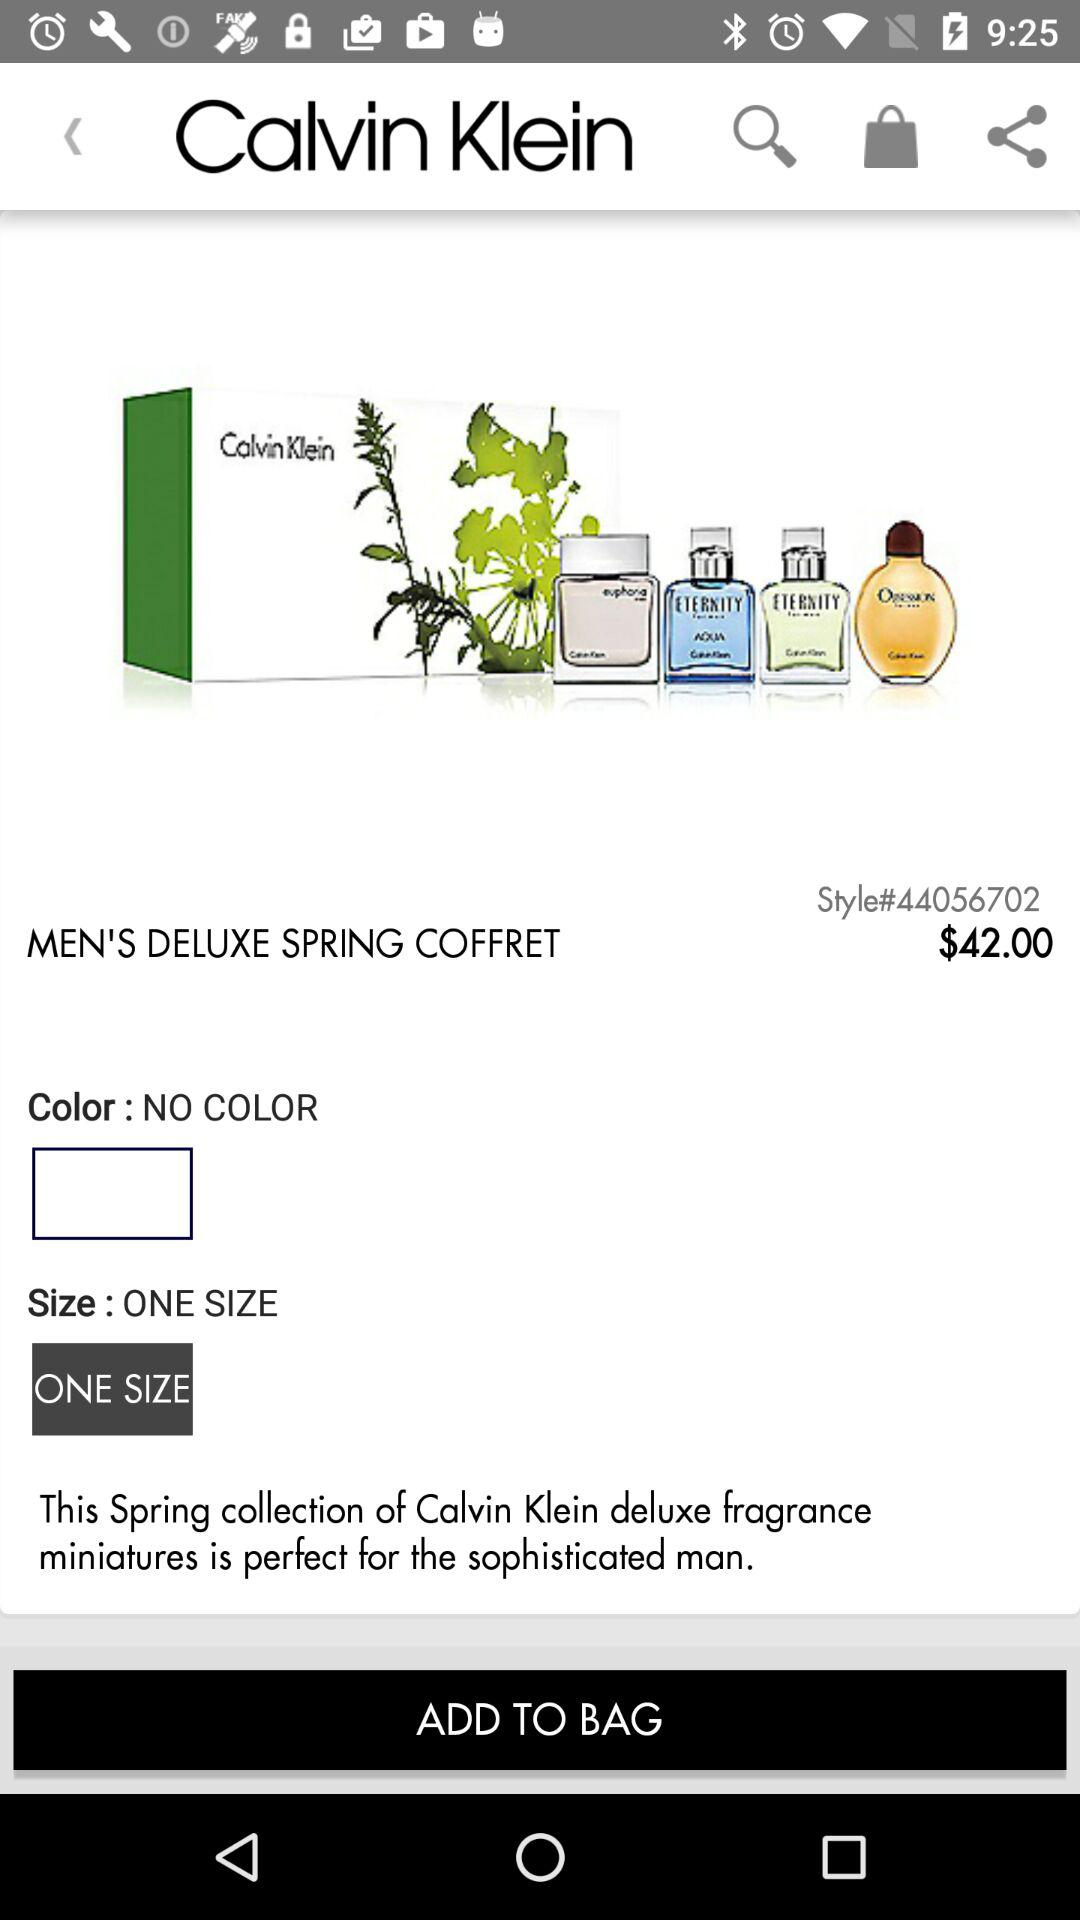What is the name of the perfume set? The name of the perfume set is "MEN'S DELUXE SPRING COFFRET". 